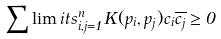Convert formula to latex. <formula><loc_0><loc_0><loc_500><loc_500>\sum \lim i t s _ { i , j = 1 } ^ { n } K ( p _ { i } , p _ { j } ) c _ { i } \overline { c _ { j } } \geq 0</formula> 